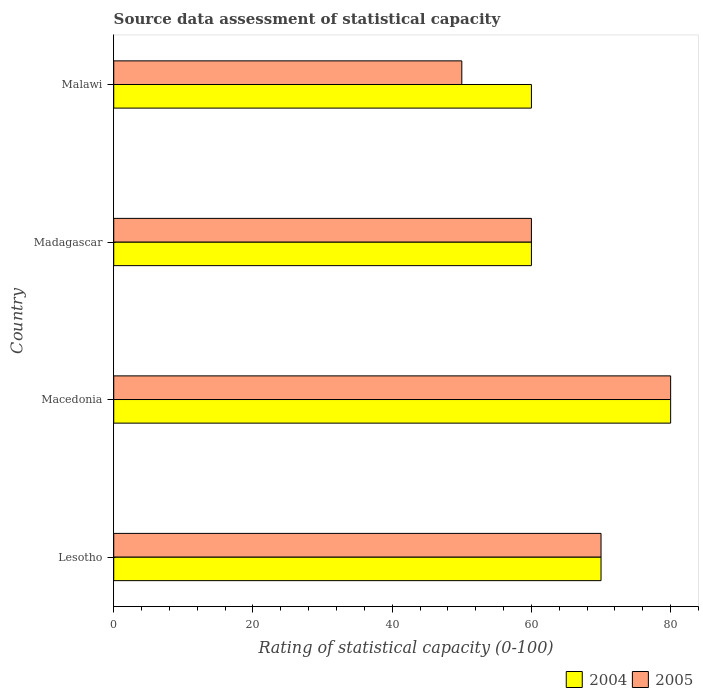How many different coloured bars are there?
Make the answer very short. 2. Are the number of bars per tick equal to the number of legend labels?
Offer a very short reply. Yes. Are the number of bars on each tick of the Y-axis equal?
Your answer should be very brief. Yes. What is the label of the 3rd group of bars from the top?
Your response must be concise. Macedonia. In how many cases, is the number of bars for a given country not equal to the number of legend labels?
Ensure brevity in your answer.  0. What is the rating of statistical capacity in 2004 in Lesotho?
Give a very brief answer. 70. Across all countries, what is the maximum rating of statistical capacity in 2005?
Provide a short and direct response. 80. In which country was the rating of statistical capacity in 2004 maximum?
Ensure brevity in your answer.  Macedonia. In which country was the rating of statistical capacity in 2005 minimum?
Ensure brevity in your answer.  Malawi. What is the total rating of statistical capacity in 2005 in the graph?
Your response must be concise. 260. What is the difference between the rating of statistical capacity in 2004 in Macedonia and the rating of statistical capacity in 2005 in Lesotho?
Ensure brevity in your answer.  10. What is the difference between the rating of statistical capacity in 2004 and rating of statistical capacity in 2005 in Macedonia?
Your response must be concise. 0. In how many countries, is the rating of statistical capacity in 2004 greater than 28 ?
Provide a succinct answer. 4. What is the ratio of the rating of statistical capacity in 2005 in Lesotho to that in Madagascar?
Your answer should be very brief. 1.17. What does the 2nd bar from the bottom in Malawi represents?
Provide a succinct answer. 2005. Are all the bars in the graph horizontal?
Provide a short and direct response. Yes. Does the graph contain any zero values?
Offer a very short reply. No. How many legend labels are there?
Provide a short and direct response. 2. What is the title of the graph?
Give a very brief answer. Source data assessment of statistical capacity. Does "1968" appear as one of the legend labels in the graph?
Keep it short and to the point. No. What is the label or title of the X-axis?
Make the answer very short. Rating of statistical capacity (0-100). What is the Rating of statistical capacity (0-100) of 2004 in Lesotho?
Offer a terse response. 70. What is the Rating of statistical capacity (0-100) in 2005 in Lesotho?
Provide a succinct answer. 70. What is the Rating of statistical capacity (0-100) in 2004 in Malawi?
Offer a very short reply. 60. Across all countries, what is the maximum Rating of statistical capacity (0-100) of 2004?
Your answer should be compact. 80. Across all countries, what is the maximum Rating of statistical capacity (0-100) of 2005?
Provide a succinct answer. 80. Across all countries, what is the minimum Rating of statistical capacity (0-100) of 2005?
Your answer should be compact. 50. What is the total Rating of statistical capacity (0-100) of 2004 in the graph?
Keep it short and to the point. 270. What is the total Rating of statistical capacity (0-100) of 2005 in the graph?
Ensure brevity in your answer.  260. What is the difference between the Rating of statistical capacity (0-100) in 2004 in Lesotho and that in Macedonia?
Offer a terse response. -10. What is the difference between the Rating of statistical capacity (0-100) in 2004 in Lesotho and that in Malawi?
Offer a terse response. 10. What is the difference between the Rating of statistical capacity (0-100) in 2005 in Lesotho and that in Malawi?
Offer a very short reply. 20. What is the difference between the Rating of statistical capacity (0-100) in 2004 in Macedonia and that in Madagascar?
Keep it short and to the point. 20. What is the difference between the Rating of statistical capacity (0-100) of 2005 in Macedonia and that in Madagascar?
Provide a succinct answer. 20. What is the difference between the Rating of statistical capacity (0-100) of 2005 in Macedonia and that in Malawi?
Offer a terse response. 30. What is the difference between the Rating of statistical capacity (0-100) of 2004 in Lesotho and the Rating of statistical capacity (0-100) of 2005 in Macedonia?
Your response must be concise. -10. What is the difference between the Rating of statistical capacity (0-100) of 2004 in Lesotho and the Rating of statistical capacity (0-100) of 2005 in Madagascar?
Give a very brief answer. 10. What is the average Rating of statistical capacity (0-100) of 2004 per country?
Keep it short and to the point. 67.5. What is the difference between the Rating of statistical capacity (0-100) in 2004 and Rating of statistical capacity (0-100) in 2005 in Lesotho?
Offer a very short reply. 0. What is the difference between the Rating of statistical capacity (0-100) in 2004 and Rating of statistical capacity (0-100) in 2005 in Macedonia?
Your answer should be very brief. 0. What is the difference between the Rating of statistical capacity (0-100) in 2004 and Rating of statistical capacity (0-100) in 2005 in Malawi?
Your response must be concise. 10. What is the ratio of the Rating of statistical capacity (0-100) of 2004 in Lesotho to that in Malawi?
Offer a very short reply. 1.17. What is the ratio of the Rating of statistical capacity (0-100) of 2004 in Macedonia to that in Madagascar?
Provide a short and direct response. 1.33. What is the ratio of the Rating of statistical capacity (0-100) of 2005 in Macedonia to that in Madagascar?
Offer a very short reply. 1.33. What is the ratio of the Rating of statistical capacity (0-100) in 2005 in Macedonia to that in Malawi?
Ensure brevity in your answer.  1.6. What is the ratio of the Rating of statistical capacity (0-100) of 2005 in Madagascar to that in Malawi?
Your answer should be compact. 1.2. What is the difference between the highest and the second highest Rating of statistical capacity (0-100) of 2005?
Offer a very short reply. 10. What is the difference between the highest and the lowest Rating of statistical capacity (0-100) of 2004?
Your answer should be very brief. 20. 